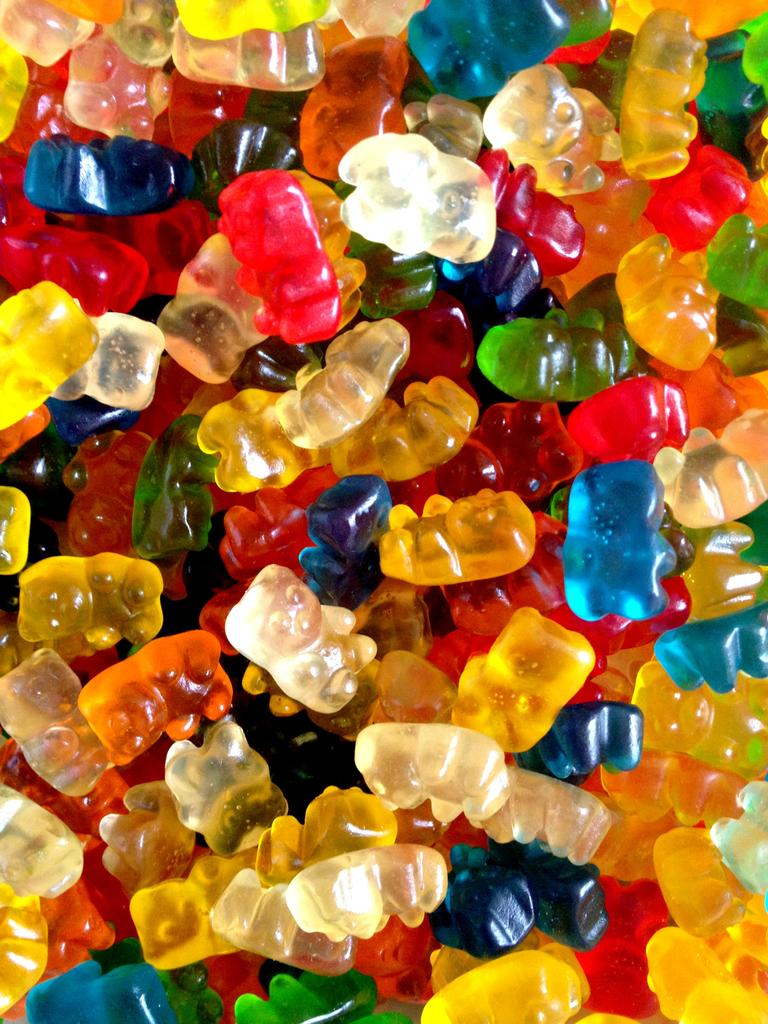What type of food is visible in the image? There are jellies in the image. What type of plate is holding the jellies in the image? There is no plate visible in the image; only the jellies are present. What is the current status of the jellies in the image? The question about the "current status" of the jellies is unclear and cannot be answered definitively based on the provided fact. 